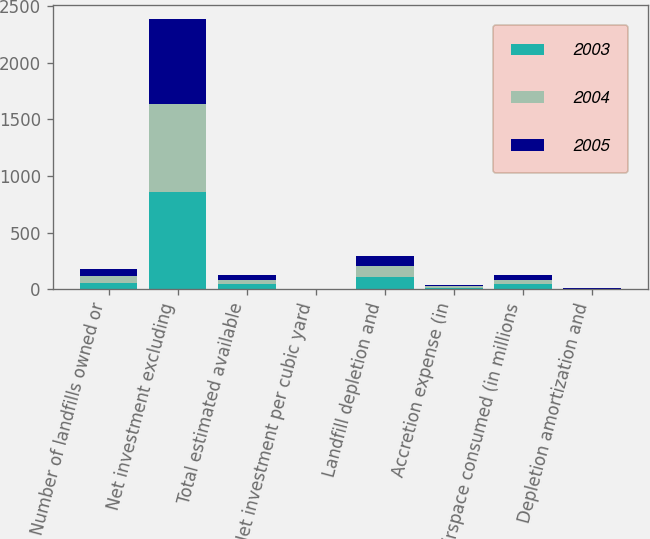<chart> <loc_0><loc_0><loc_500><loc_500><stacked_bar_chart><ecel><fcel>Number of landfills owned or<fcel>Net investment excluding<fcel>Total estimated available<fcel>Net investment per cubic yard<fcel>Landfill depletion and<fcel>Accretion expense (in<fcel>Airspace consumed (in millions<fcel>Depletion amortization and<nl><fcel>2003<fcel>59<fcel>856.5<fcel>42.1<fcel>0.49<fcel>104.2<fcel>14.5<fcel>43.6<fcel>2.72<nl><fcel>2004<fcel>58<fcel>782.7<fcel>42.1<fcel>0.45<fcel>98.4<fcel>13.7<fcel>42.1<fcel>2.66<nl><fcel>2005<fcel>58<fcel>751.4<fcel>42.1<fcel>0.43<fcel>92.8<fcel>12.7<fcel>39.3<fcel>2.68<nl></chart> 